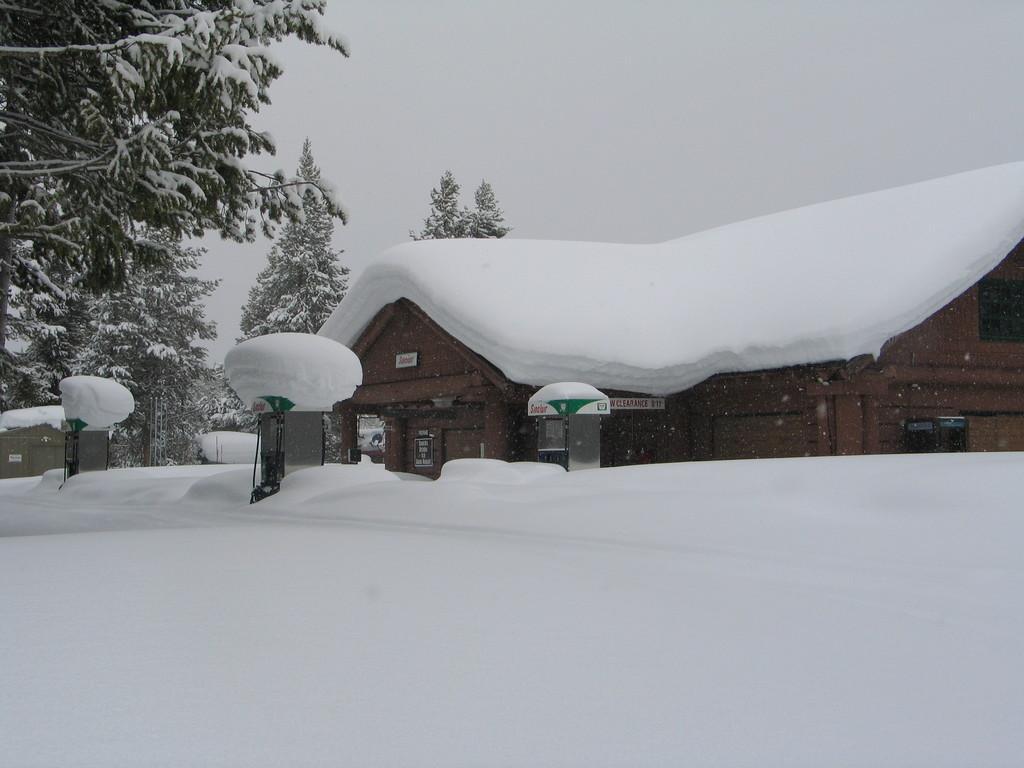Describe this image in one or two sentences. In this picture we can see snow, boxes, boards, house and trees. In the background of the image we can see sky. 